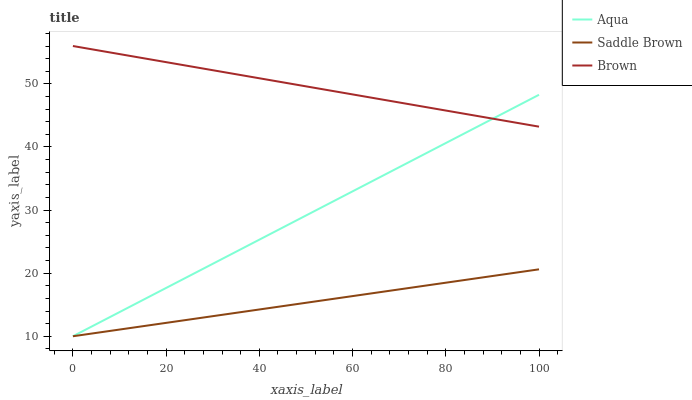Does Saddle Brown have the minimum area under the curve?
Answer yes or no. Yes. Does Brown have the maximum area under the curve?
Answer yes or no. Yes. Does Aqua have the minimum area under the curve?
Answer yes or no. No. Does Aqua have the maximum area under the curve?
Answer yes or no. No. Is Saddle Brown the smoothest?
Answer yes or no. Yes. Is Brown the roughest?
Answer yes or no. Yes. Is Aqua the smoothest?
Answer yes or no. No. Is Aqua the roughest?
Answer yes or no. No. Does Aqua have the highest value?
Answer yes or no. No. Is Saddle Brown less than Brown?
Answer yes or no. Yes. Is Brown greater than Saddle Brown?
Answer yes or no. Yes. Does Saddle Brown intersect Brown?
Answer yes or no. No. 